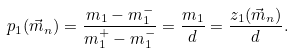<formula> <loc_0><loc_0><loc_500><loc_500>p _ { 1 } ( \vec { m } _ { n } ) = \frac { m _ { 1 } - m _ { 1 } ^ { - } } { m _ { 1 } ^ { + } - m _ { 1 } ^ { - } } = \frac { m _ { 1 } } { d } = \frac { z _ { 1 } ( \vec { m } _ { n } ) } { d } .</formula> 